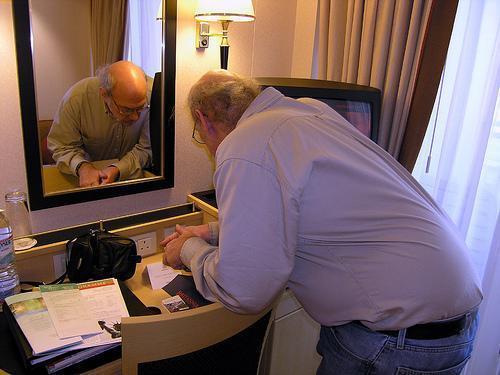How many people in picture?
Give a very brief answer. 1. 